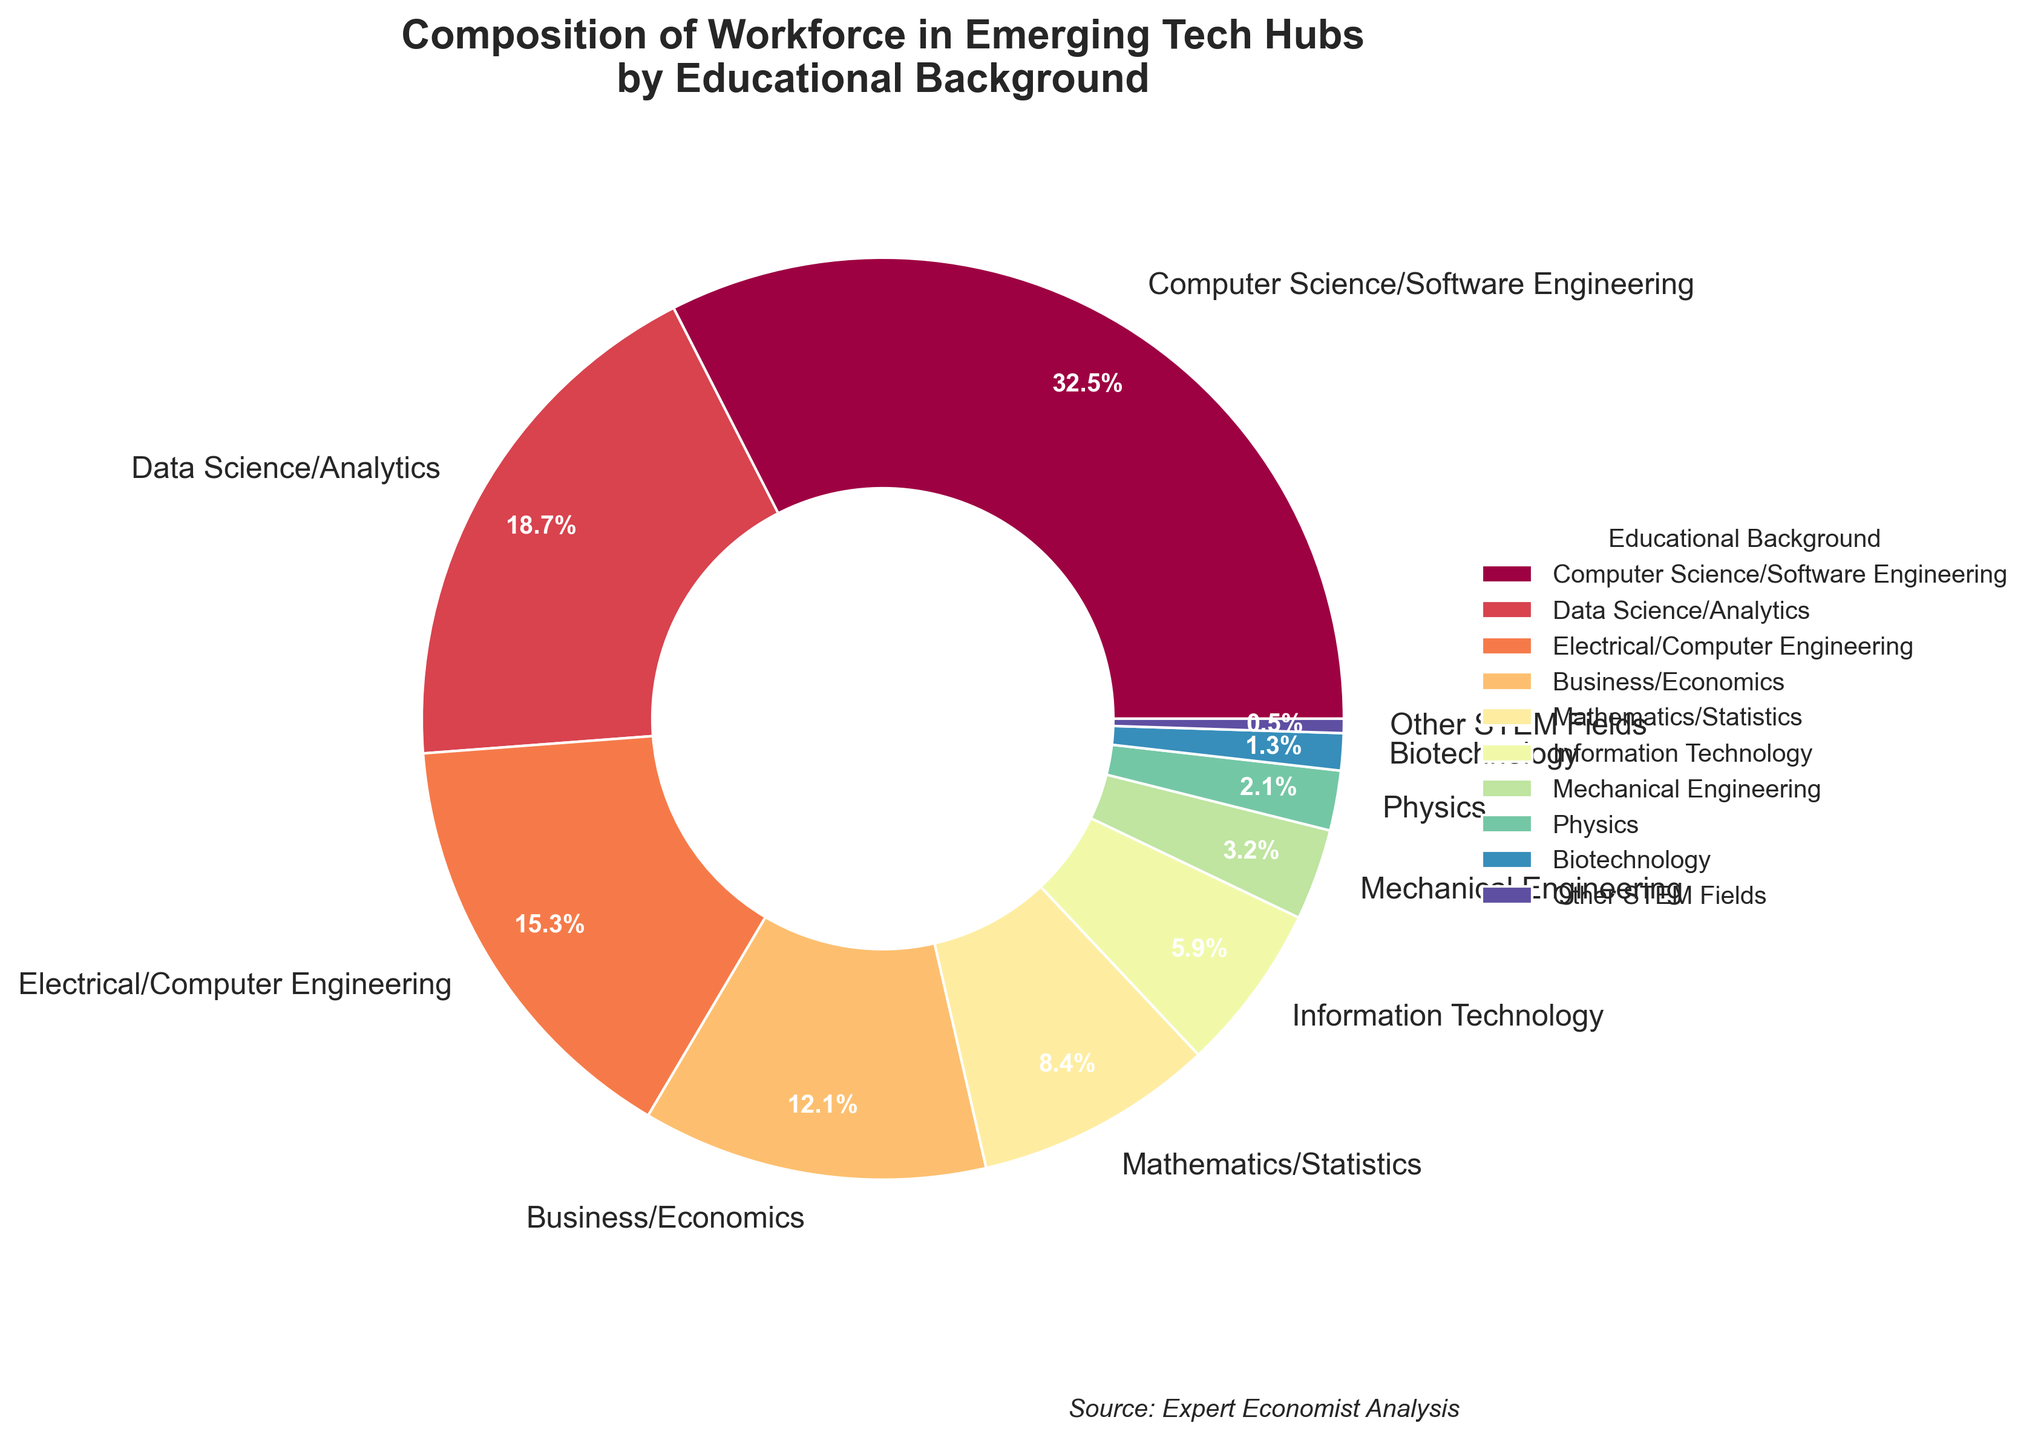What percentage of the workforce in emerging tech hubs has an educational background in Business/Economics or Electrical/Computer Engineering combined? To find the combined percentage, add the percentages for Business/Economics (12.1%) and Electrical/Computer Engineering (15.3%). So, \(12.1\% + 15.3\% = 27.4\%\)
Answer: 27.4% Which educational background has the lowest representation in the workforce? Look at the slice of the pie chart with the smallest percentage. "Other STEM Fields" has the smallest representation at 0.5%.
Answer: Other STEM Fields Is the representation of Computer Science/Software Engineering more than double that of Data Science/Analytics? Compare the percentages: Computer Science/Software Engineering is 32.5% and Data Science/Analytics is 18.7%. \(32.5\) is not more than double \(18.7\) since \(18.7 \times 2 = 37.4\), which is greater than \(32.5\).
Answer: No Between Data Science/Analytics and Mathematics/Statistics, which educational background has a higher percentage, and by how much? Data Science/Analytics and Mathematics/Statistics have percentages of 18.7% and 8.4%, respectively. The difference is \(18.7\% - 8.4\% = 10.3\%\).
Answer: Data Science/Analytics by 10.3% What's the combined percentage of educational backgrounds in STEM fields (excluding Business/Economics)? Combine the percentages for all the specified STEM fields: 
Computer Science/Software Engineering (32.5%), Data Science/Analytics (18.7%), Electrical/Computer Engineering (15.3%), Mathematics/Statistics (8.4%), Information Technology (5.9%), Mechanical Engineering (3.2%), Physics (2.1%), Biotechnology (1.3%), and Other STEM Fields (0.5%). Adding these gives \(32.5 + 18.7 + 15.3 + 8.4 + 5.9 + 3.2 + 2.1 + 1.3 + 0.5 = 87.9\)%
Answer: 87.9% How many educational backgrounds have a representation of 5% or less? Look at the pie chart slices: Information Technology (5.9%), Mechanical Engineering (3.2%), Physics (2.1%), Biotechnology (1.3%), and Other STEM Fields (0.5%). Only Mechanical Engineering, Physics, Biotechnology, and Other STEM Fields have representations of 5% or less. There are 4 educational backgrounds in this range.
Answer: 4 Which category has a larger share, Mechanical Engineering or Mathematics/Statistics, and by what margin? Mechanical Engineering is 3.2% and Mathematics/Statistics is 8.4%. The margin is \(8.4\% - 3.2\% = 5.2\%\).
Answer: Mathematics/Statistics by 5.2% How does the representation of Data Science/Analytics compare with the total of Information Technology and Mechanical Engineering combined? Data Science/Analytics is 18.7%, and the combined total of Information Technology (5.9%) and Mechanical Engineering (3.2%) is \(5.9 + 3.2 = 9.1\%\). Since \(18.7\% > 9.1\%\), Data Science/Analytics has a higher representation.
Answer: Data Science/Analytics is higher Among the listed educational backgrounds, which is the third most represented in the workforce? From the pie chart, the three highest percentages are Computer Science/Software Engineering (32.5%), Data Science/Analytics (18.7%), and Electrical/Computer Engineering (15.3%). The third most represented background is Electrical/Computer Engineering.
Answer: Electrical/Computer Engineering 